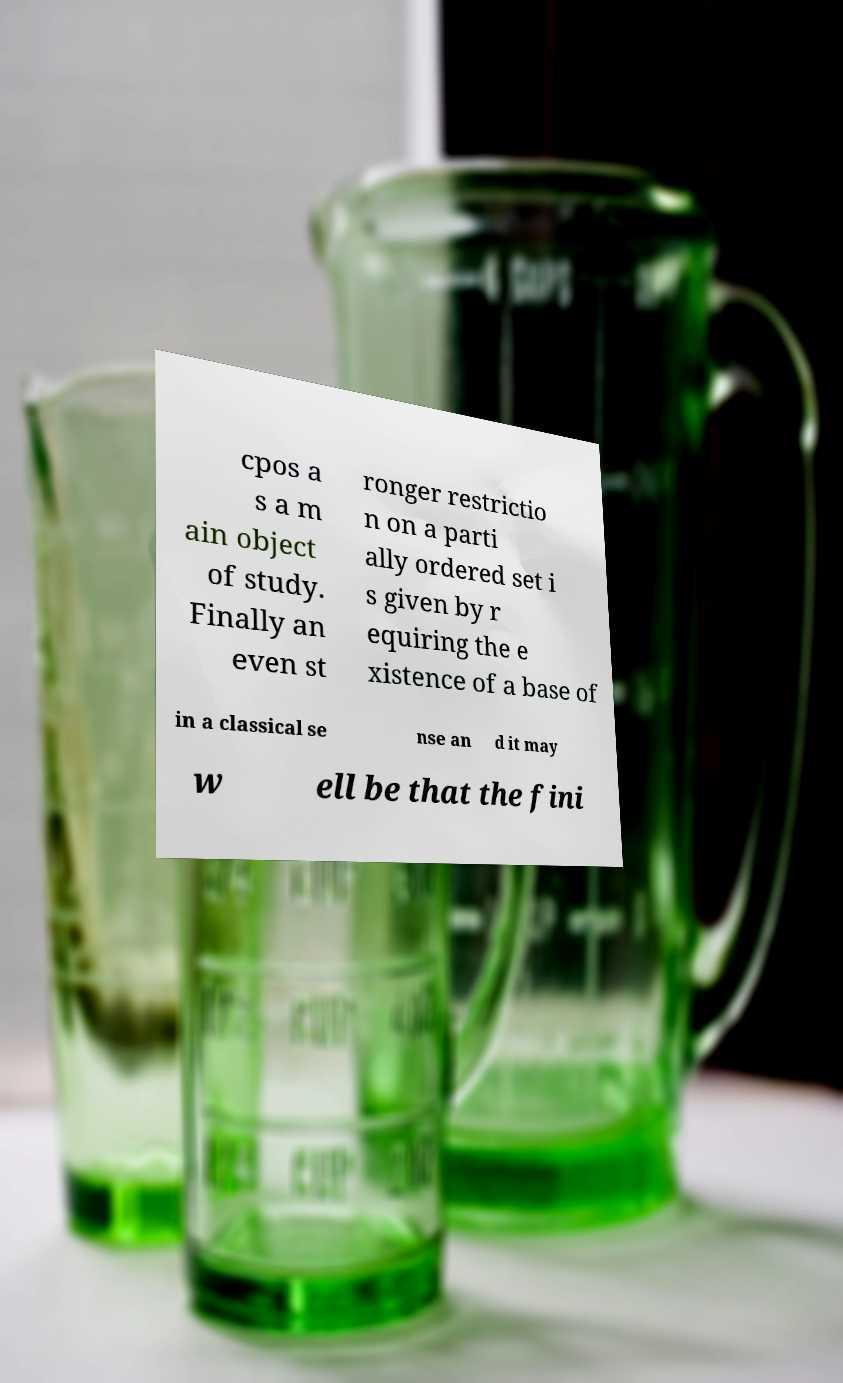Could you assist in decoding the text presented in this image and type it out clearly? cpos a s a m ain object of study. Finally an even st ronger restrictio n on a parti ally ordered set i s given by r equiring the e xistence of a base of in a classical se nse an d it may w ell be that the fini 